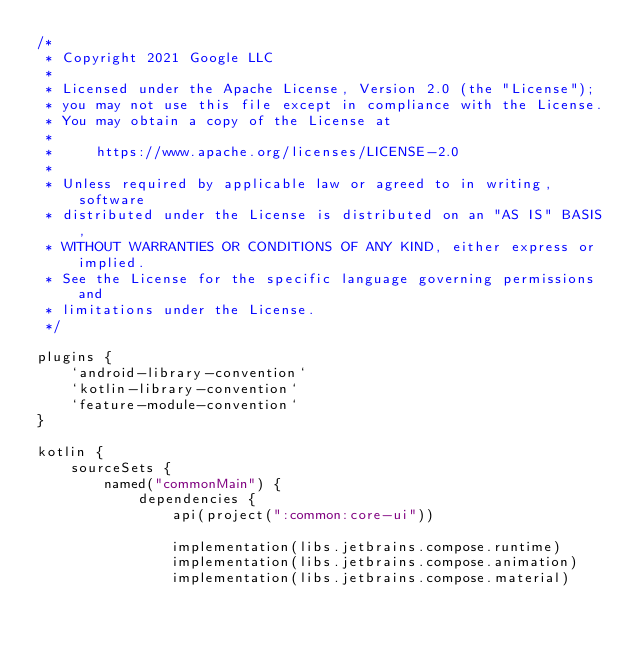<code> <loc_0><loc_0><loc_500><loc_500><_Kotlin_>/*
 * Copyright 2021 Google LLC
 *
 * Licensed under the Apache License, Version 2.0 (the "License");
 * you may not use this file except in compliance with the License.
 * You may obtain a copy of the License at
 *
 *     https://www.apache.org/licenses/LICENSE-2.0
 *
 * Unless required by applicable law or agreed to in writing, software
 * distributed under the License is distributed on an "AS IS" BASIS,
 * WITHOUT WARRANTIES OR CONDITIONS OF ANY KIND, either express or implied.
 * See the License for the specific language governing permissions and
 * limitations under the License.
 */

plugins {
    `android-library-convention`
    `kotlin-library-convention`
    `feature-module-convention`
}

kotlin {
    sourceSets {
        named("commonMain") {
            dependencies {
                api(project(":common:core-ui"))

                implementation(libs.jetbrains.compose.runtime)
                implementation(libs.jetbrains.compose.animation)
                implementation(libs.jetbrains.compose.material)</code> 